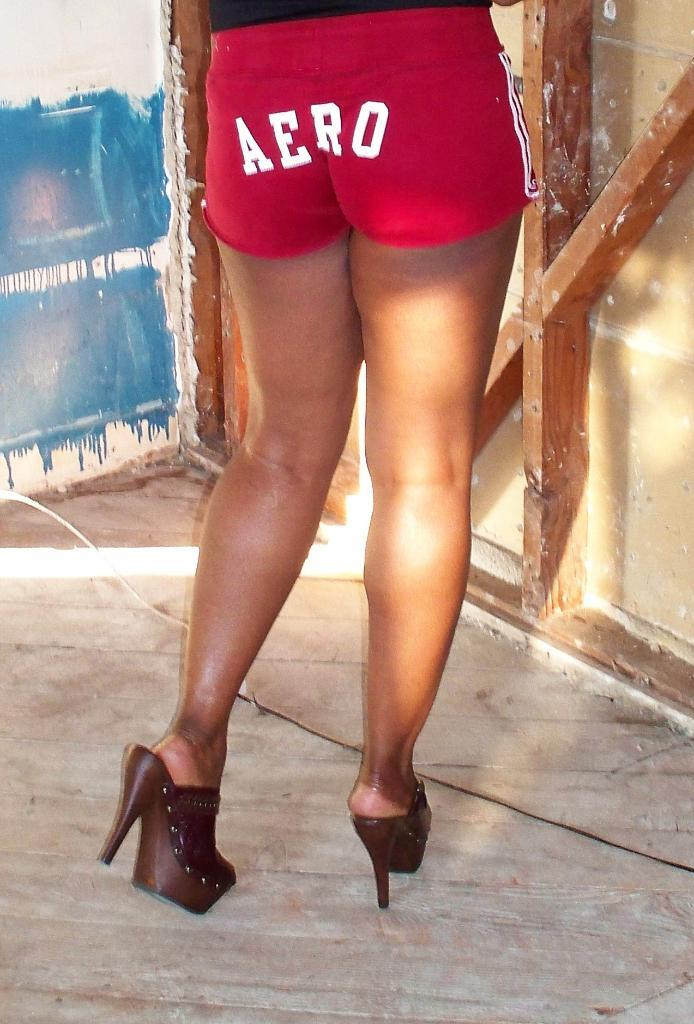<image>
Provide a brief description of the given image. A woman in shorts that say Aero on the back. 